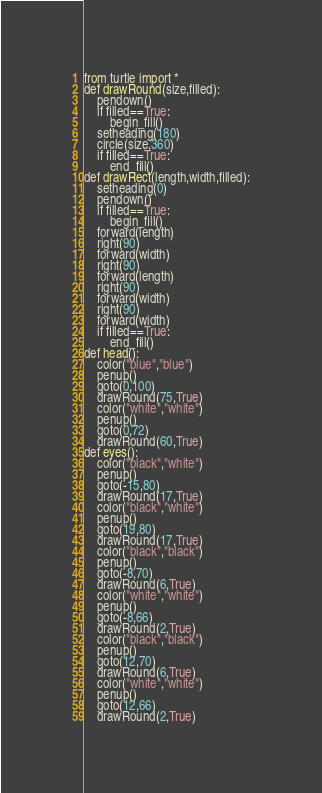Convert code to text. <code><loc_0><loc_0><loc_500><loc_500><_Python_>from turtle import *
def drawRound(size,filled):
    pendown()
    if filled==True:
        begin_fill()
    setheading(180)
    circle(size,360)
    if filled==True:
        end_fill()
def drawRect(length,width,filled):
    setheading(0)
    pendown()
    if filled==True:
        begin_fill()
    forward(length)
    right(90)
    forward(width)
    right(90)
    forward(length)
    right(90)
    forward(width)
    right(90)
    forward(width)
    if filled==True:
        end_fill()
def head():
    color("blue","blue")
    penup()
    goto(0,100)
    drawRound(75,True)
    color("white","white")
    penup()
    goto(0,72)
    drawRound(60,True) 
def eyes():
    color("black","white") 
    penup()
    goto(-15,80)
    drawRound(17,True) 
    color("black","white") 
    penup()
    goto(19,80)
    drawRound(17,True)
    color("black","black") 
    penup()
    goto(-8,70)
    drawRound(6,True)   
    color("white","white") 
    penup()
    goto(-8,66)
    drawRound(2,True)      
    color("black","black") 
    penup()
    goto(12,70)
    drawRound(6,True)   
    color("white","white") 
    penup()
    goto(12,66)
    drawRound(2,True) </code> 